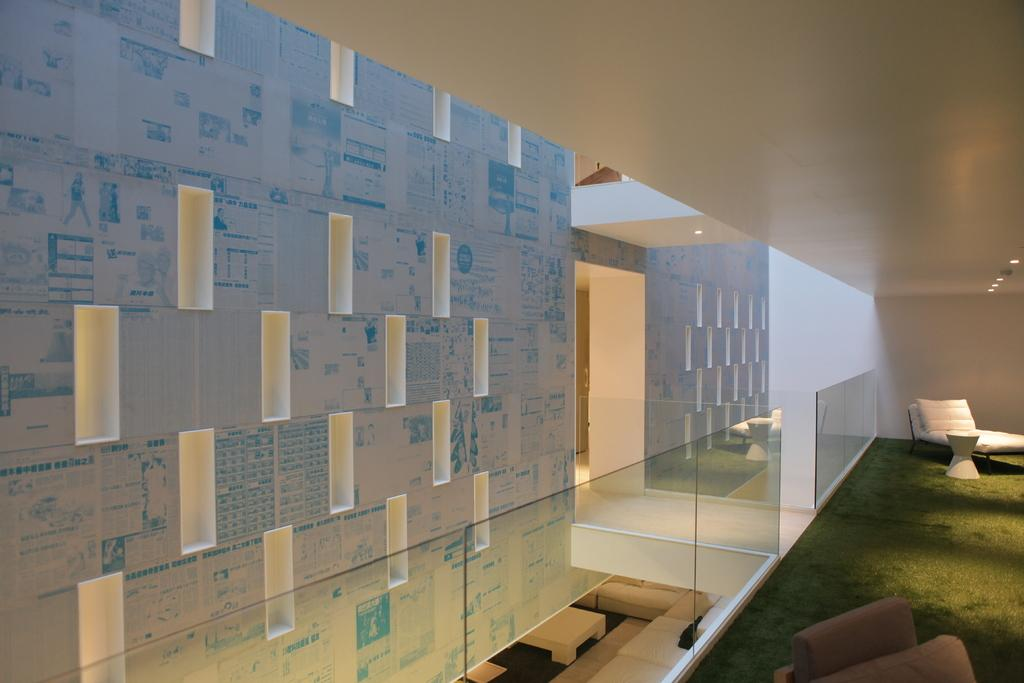What is one of the objects in the image? There is a mirror in the image. What type of natural environment can be seen in the image? There is grass visible in the image. What type of furniture is in the image? There is a stool in the image. What type of structure is in the image? There is a wall in the image. What type of lighting is visible in the image? There are ceiling lights visible in the image. How many crates are stacked on top of each other in the image? There are no crates present in the image. What type of print is visible on the wall in the image? There is no print visible on the wall in the image. 